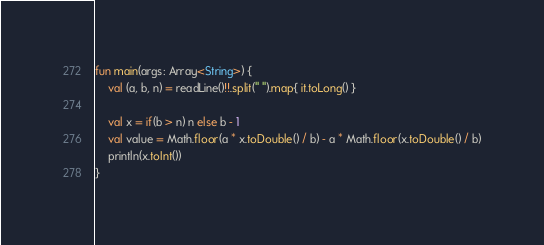Convert code to text. <code><loc_0><loc_0><loc_500><loc_500><_Kotlin_>fun main(args: Array<String>) {
    val (a, b, n) = readLine()!!.split(" ").map{ it.toLong() }

    val x = if(b > n) n else b - 1
    val value = Math.floor(a * x.toDouble() / b) - a * Math.floor(x.toDouble() / b)
    println(x.toInt())
}</code> 